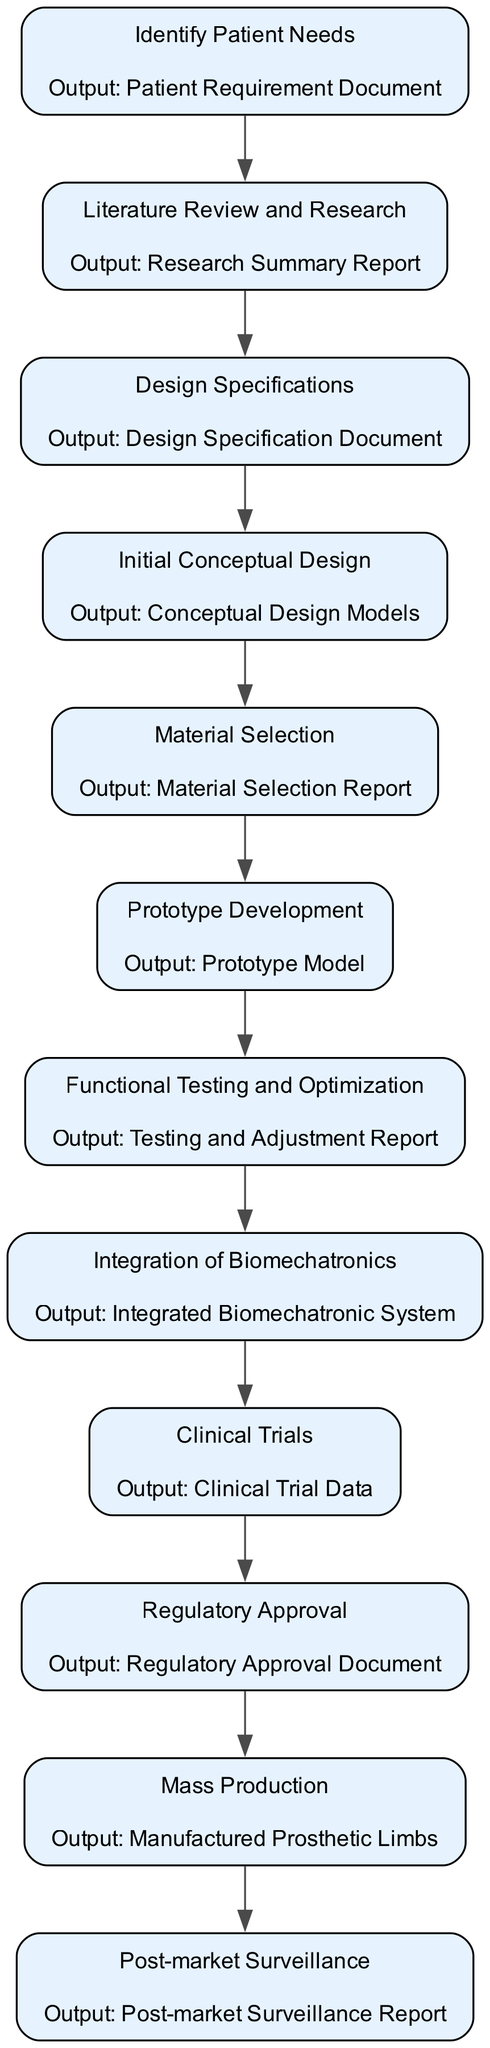What is the first step in the prosthetic limb design process? The first step is "Identify Patient Needs," which is the initial element in the flow chart.
Answer: Identify Patient Needs What is the output of "Material Selection"? The output of "Material Selection" is detailed in the flow chart as "Material Selection Report," which follows that specific node.
Answer: Material Selection Report How many steps are there in the design process? By counting the nodes presented in the diagram, there are a total of 12 steps in the process.
Answer: 12 What comes after "Prototype Development"? Following "Prototype Development," the next step is "Functional Testing and Optimization," which is indicated by the directed edge connecting the nodes.
Answer: Functional Testing and Optimization Which step involves patient interaction? The step that involves patient interaction is "Clinical Trials," where prosthetic limbs are tested with patients in real-world conditions, as shown in the diagram.
Answer: Clinical Trials What is the last step in the design process? The final step in the diagram is "Post-market Surveillance," which tracks the performance of the product after it has been launched.
Answer: Post-market Surveillance Which output is associated with the "Integration of Biomechatronics"? The output associated with "Integration of Biomechatronics" is “Integrated Biomechatronic System," as stated in the diagram next to that node.
Answer: Integrated Biomechatronic System Which two steps directly precede "Mass Production"? "Regulatory Approval" and "Clinical Trials" are the two steps that come immediately before "Mass Production," as indicated in the flow of the diagram.
Answer: Regulatory Approval, Clinical Trials What step requires submitting designs to regulatory bodies? The step requiring submission to regulatory bodies is "Regulatory Approval," which directly follows the testing phases in the workflow.
Answer: Regulatory Approval 